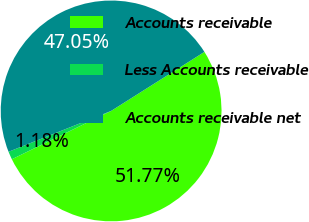<chart> <loc_0><loc_0><loc_500><loc_500><pie_chart><fcel>Accounts receivable<fcel>Less Accounts receivable<fcel>Accounts receivable net<nl><fcel>51.76%<fcel>1.18%<fcel>47.05%<nl></chart> 